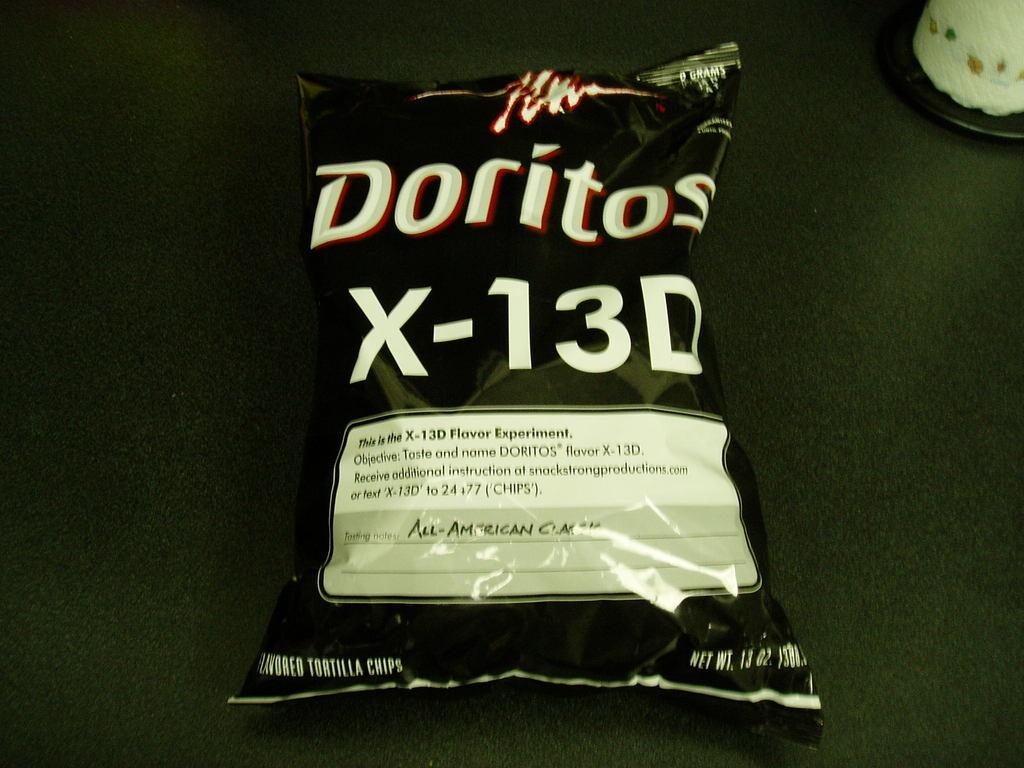How many ounces?
Your answer should be very brief. 13. 